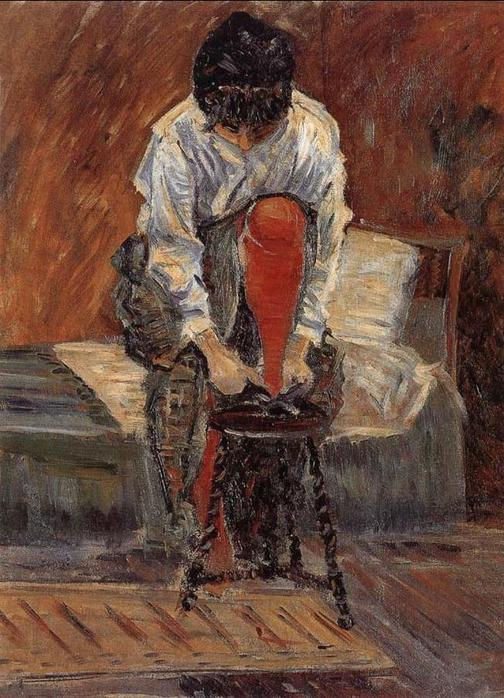Imagine a realistic yet detailed backstory for this woman. This woman is named Eleanor, a schoolteacher in a small, quaint village. She lives alone in a modest home, finding joy in the simplicity of her life. Each morning, Eleanor wakes up early to prepare her lessons, ensuring she inspires her students. Her white blouse and red skirt are her favorite attire, symbolizing the passion she holds for teaching. After school, she spends her evenings reading literature and knitting by the fireplace. Today, as seen in the painting, she returned from a long day at school, deeply engrossed in thoughts about her students’ progress, especially a young boy struggling with reading. Determined to help him come out of his shell, she plans to introduce him to a new book series the next day. 